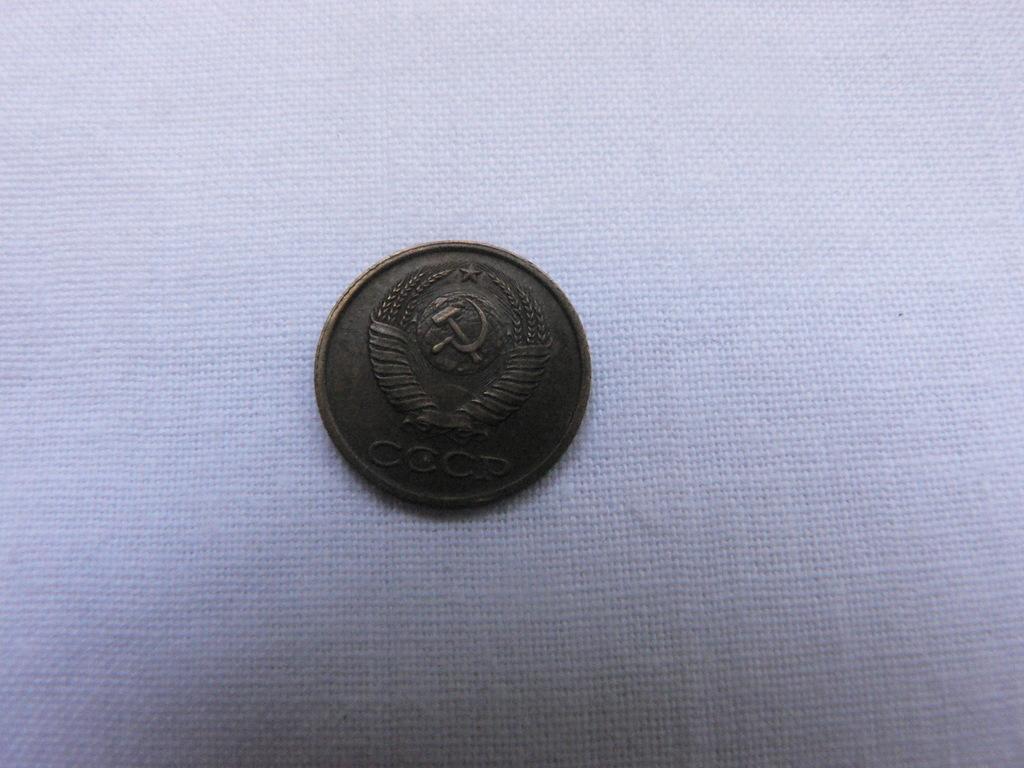What are the 4 letters on this coin?
Offer a terse response. Cccp. 